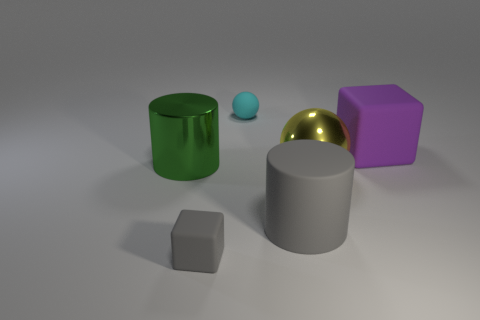Add 1 big yellow spheres. How many objects exist? 7 Subtract all cubes. How many objects are left? 4 Add 5 matte balls. How many matte balls are left? 6 Add 4 yellow cylinders. How many yellow cylinders exist? 4 Subtract 0 blue balls. How many objects are left? 6 Subtract all tiny rubber things. Subtract all green metal spheres. How many objects are left? 4 